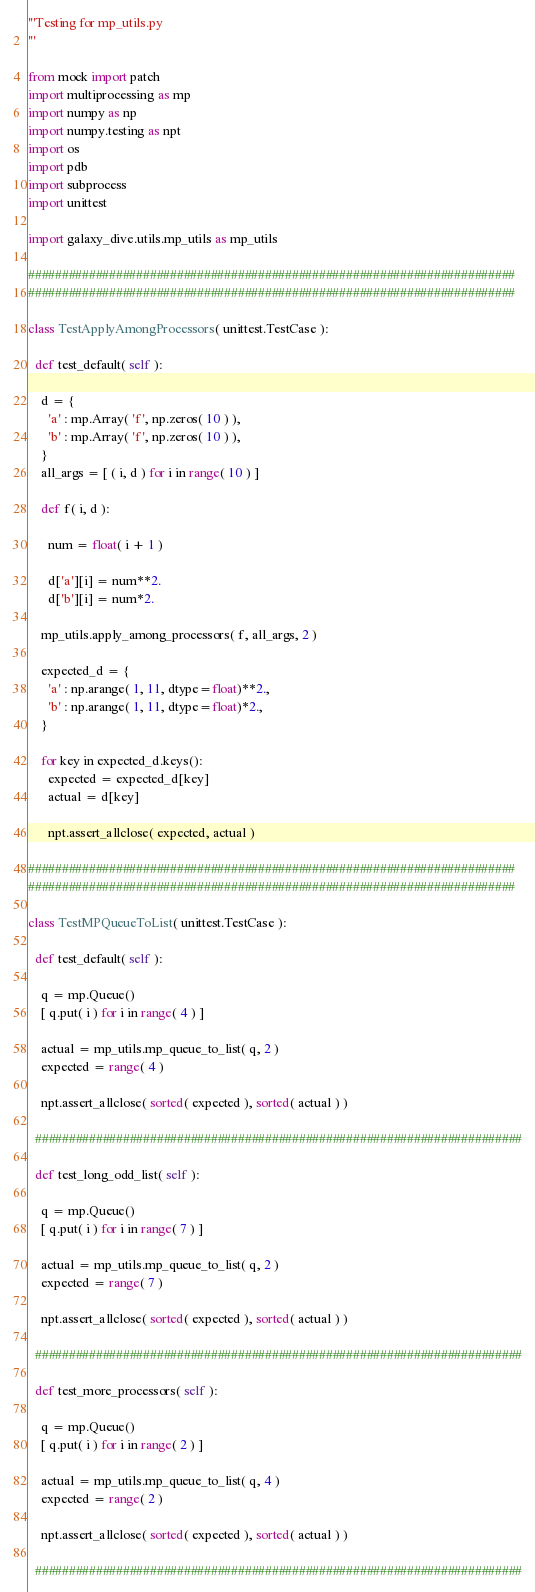<code> <loc_0><loc_0><loc_500><loc_500><_Python_>'''Testing for mp_utils.py
'''

from mock import patch
import multiprocessing as mp
import numpy as np
import numpy.testing as npt
import os
import pdb
import subprocess
import unittest

import galaxy_dive.utils.mp_utils as mp_utils

########################################################################
########################################################################

class TestApplyAmongProcessors( unittest.TestCase ):

  def test_default( self ):

    d = {
      'a' : mp.Array( 'f', np.zeros( 10 ) ),
      'b' : mp.Array( 'f', np.zeros( 10 ) ),
    }
    all_args = [ ( i, d ) for i in range( 10 ) ]

    def f( i, d ):

      num = float( i + 1 )

      d['a'][i] = num**2.
      d['b'][i] = num*2.

    mp_utils.apply_among_processors( f, all_args, 2 )

    expected_d = {
      'a' : np.arange( 1, 11, dtype=float)**2.,
      'b' : np.arange( 1, 11, dtype=float)*2.,
    }

    for key in expected_d.keys():
      expected = expected_d[key]
      actual = d[key]

      npt.assert_allclose( expected, actual )
    
########################################################################
########################################################################

class TestMPQueueToList( unittest.TestCase ):

  def test_default( self ):

    q = mp.Queue()
    [ q.put( i ) for i in range( 4 ) ]
    
    actual = mp_utils.mp_queue_to_list( q, 2 )
    expected = range( 4 )

    npt.assert_allclose( sorted( expected ), sorted( actual ) )

  ########################################################################

  def test_long_odd_list( self ):

    q = mp.Queue()
    [ q.put( i ) for i in range( 7 ) ]
    
    actual = mp_utils.mp_queue_to_list( q, 2 )
    expected = range( 7 )

    npt.assert_allclose( sorted( expected ), sorted( actual ) )

  ########################################################################

  def test_more_processors( self ):

    q = mp.Queue()
    [ q.put( i ) for i in range( 2 ) ]
    
    actual = mp_utils.mp_queue_to_list( q, 4 )
    expected = range( 2 )

    npt.assert_allclose( sorted( expected ), sorted( actual ) )

  ########################################################################
</code> 